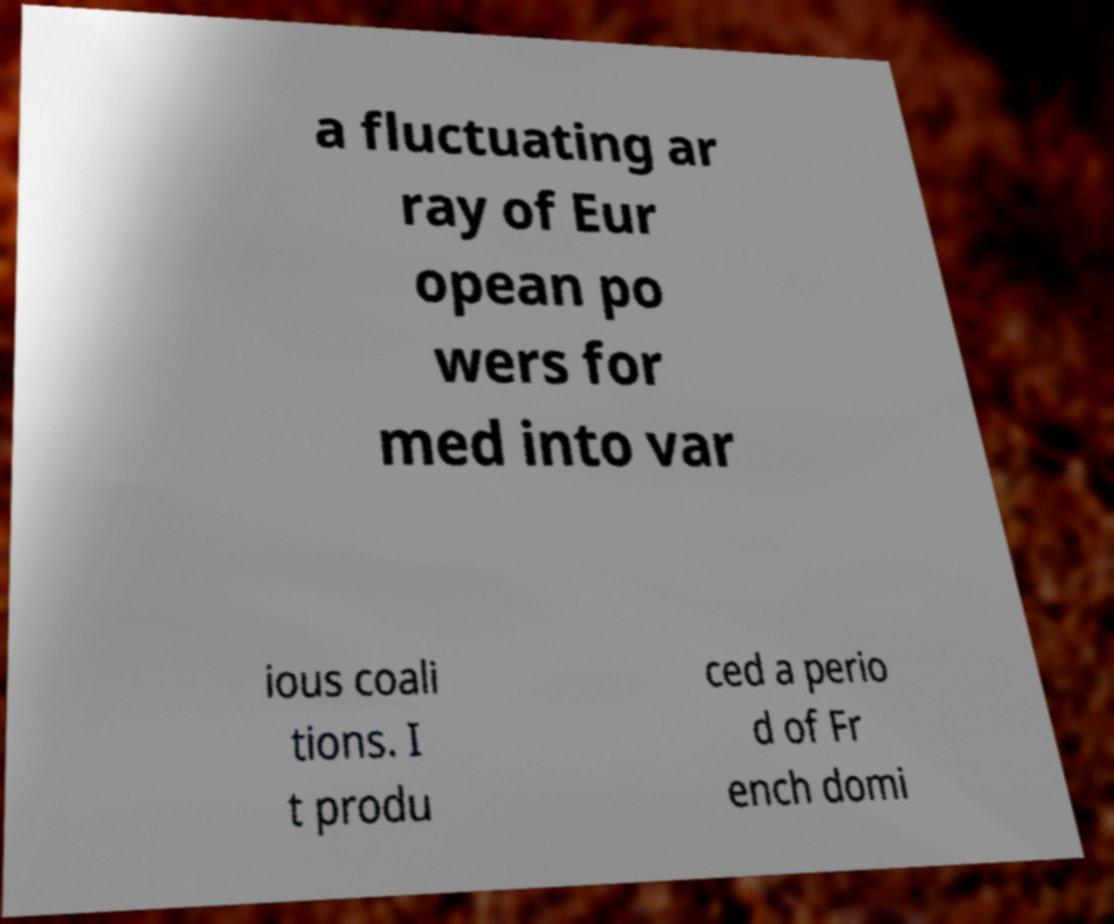Could you assist in decoding the text presented in this image and type it out clearly? a fluctuating ar ray of Eur opean po wers for med into var ious coali tions. I t produ ced a perio d of Fr ench domi 